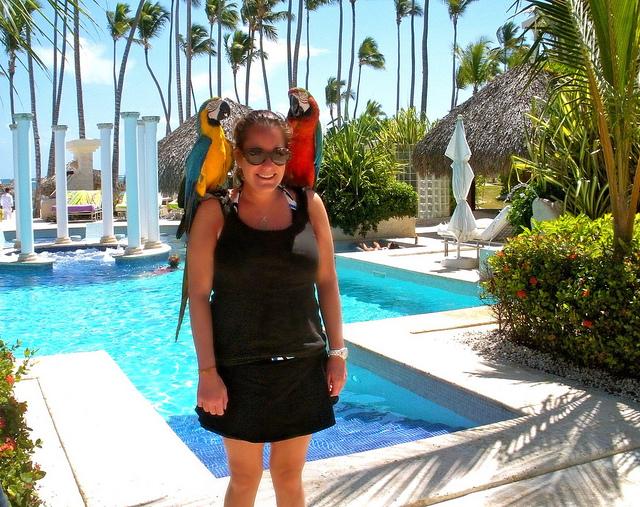What look does the woman have on her face?
Quick response, please. Happy. Is the water blue?
Answer briefly. Yes. How many birds is the woman holding?
Answer briefly. 2. 